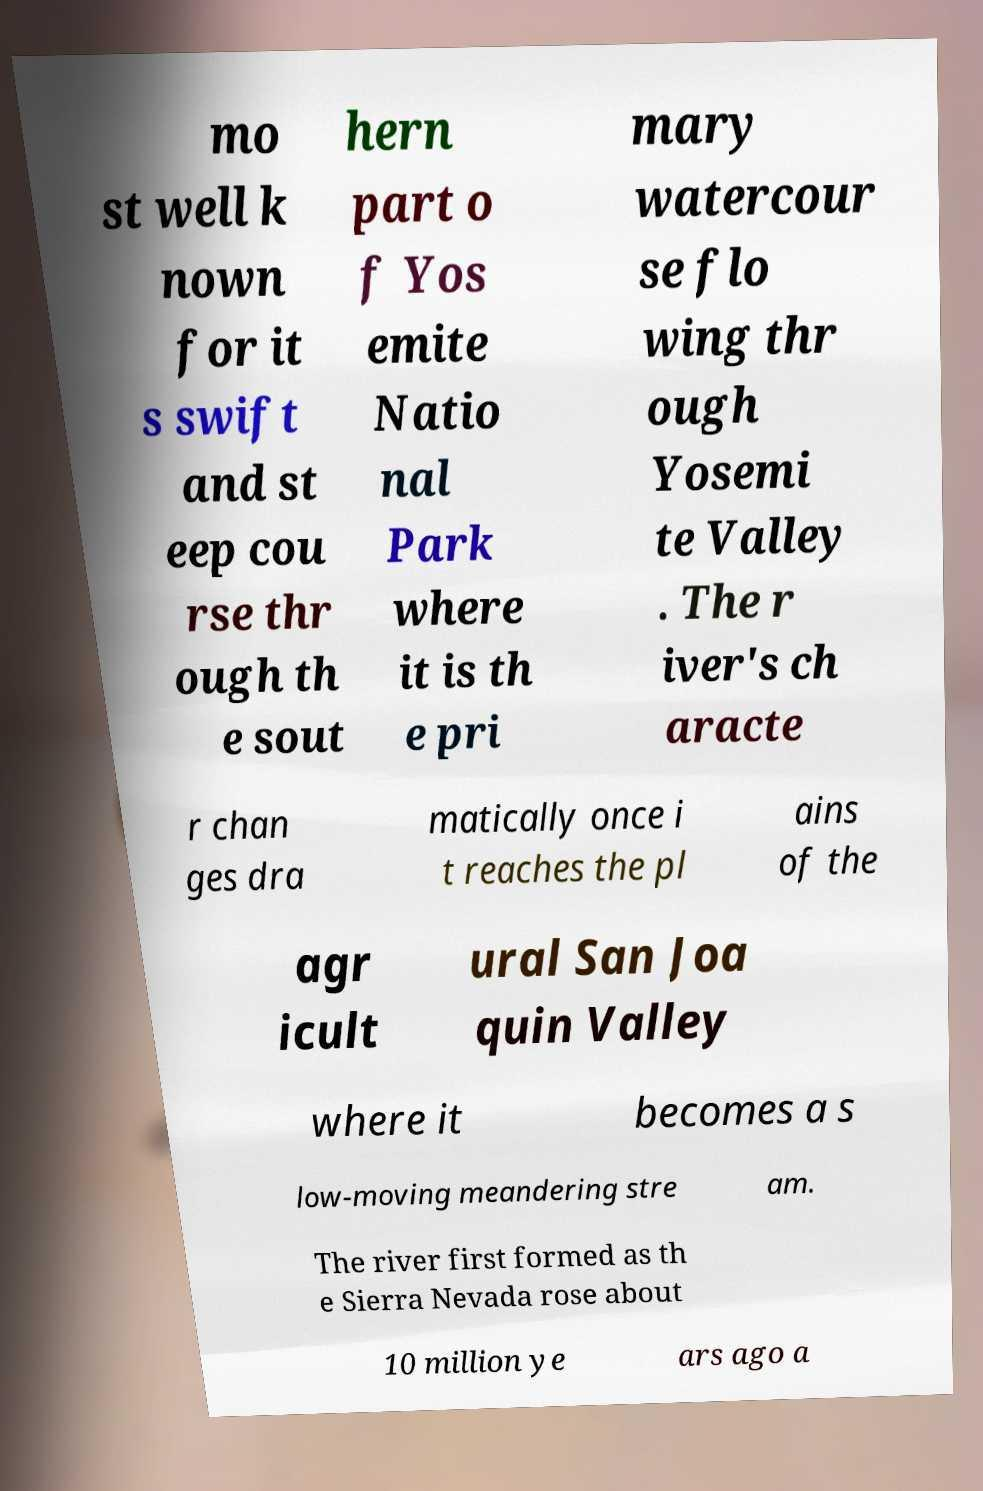Could you assist in decoding the text presented in this image and type it out clearly? mo st well k nown for it s swift and st eep cou rse thr ough th e sout hern part o f Yos emite Natio nal Park where it is th e pri mary watercour se flo wing thr ough Yosemi te Valley . The r iver's ch aracte r chan ges dra matically once i t reaches the pl ains of the agr icult ural San Joa quin Valley where it becomes a s low-moving meandering stre am. The river first formed as th e Sierra Nevada rose about 10 million ye ars ago a 